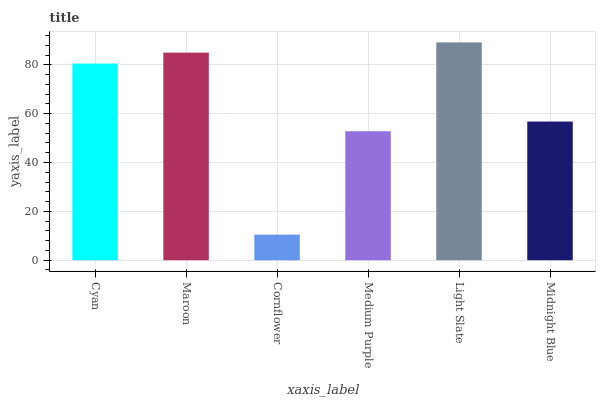Is Cornflower the minimum?
Answer yes or no. Yes. Is Light Slate the maximum?
Answer yes or no. Yes. Is Maroon the minimum?
Answer yes or no. No. Is Maroon the maximum?
Answer yes or no. No. Is Maroon greater than Cyan?
Answer yes or no. Yes. Is Cyan less than Maroon?
Answer yes or no. Yes. Is Cyan greater than Maroon?
Answer yes or no. No. Is Maroon less than Cyan?
Answer yes or no. No. Is Cyan the high median?
Answer yes or no. Yes. Is Midnight Blue the low median?
Answer yes or no. Yes. Is Light Slate the high median?
Answer yes or no. No. Is Cyan the low median?
Answer yes or no. No. 